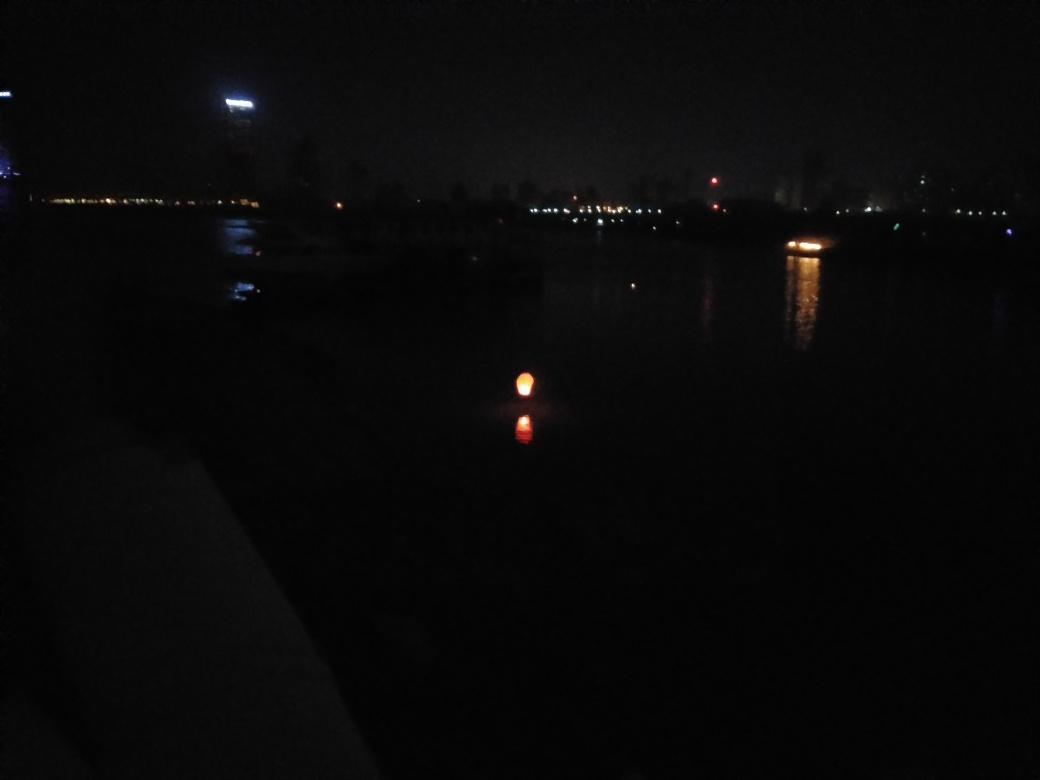What is the lighting condition in the image? The image shows a scene during nighttime with very low ambient light. The primary source of light appears to be a warm, possibly artificial light reflecting off the water's surface. Distant city lights offer minimal illumination in the background. 